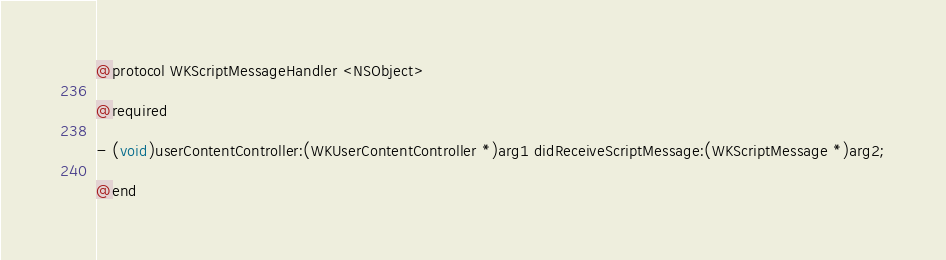Convert code to text. <code><loc_0><loc_0><loc_500><loc_500><_C_>@protocol WKScriptMessageHandler <NSObject>

@required

- (void)userContentController:(WKUserContentController *)arg1 didReceiveScriptMessage:(WKScriptMessage *)arg2;

@end
</code> 